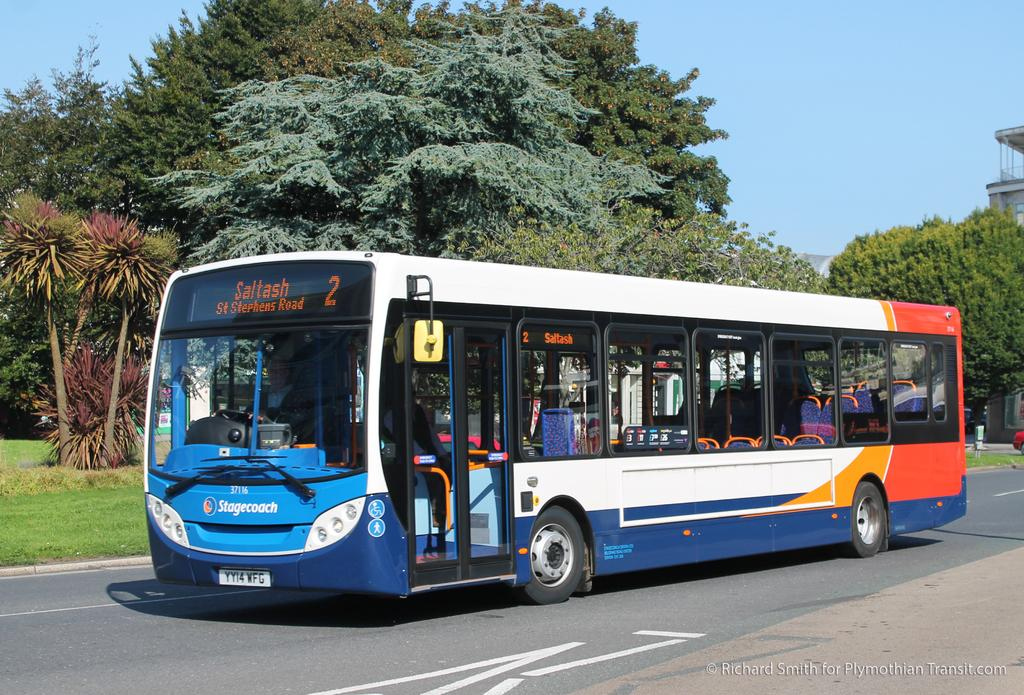<image>
Relay a brief, clear account of the picture shown. A blue, red and white stagecoach bus on the street with the word Saltash in front. 